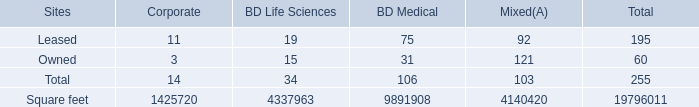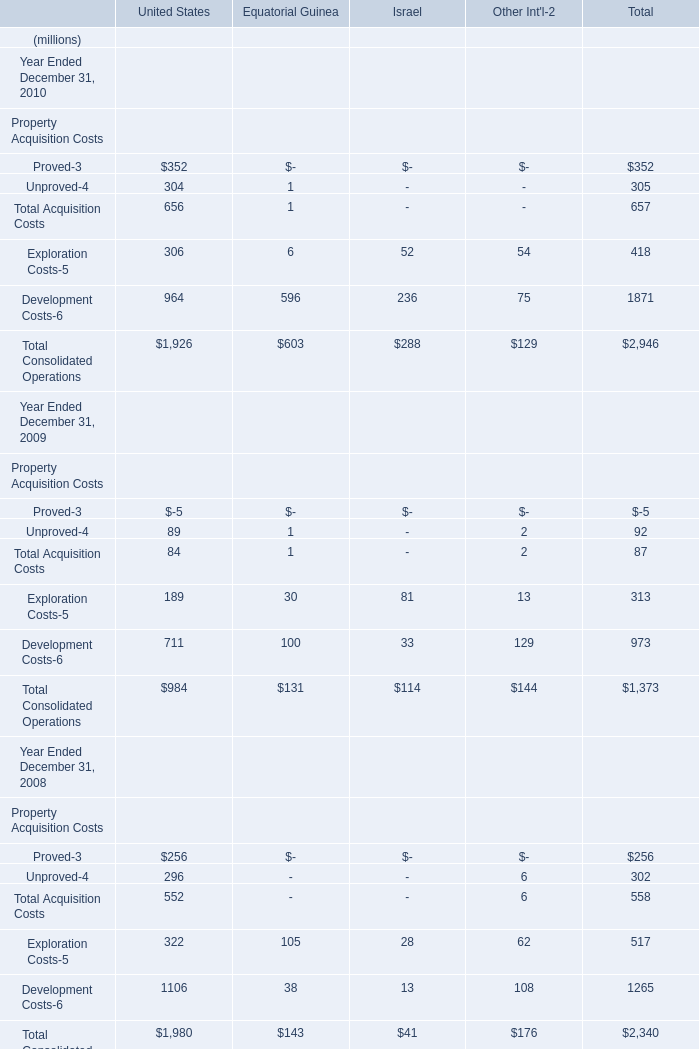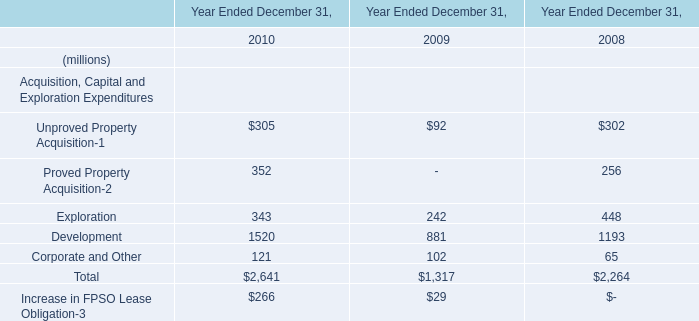If the Total Acquisition Costs in terms of United States develops with the same growth rate in 2010, what will it reach in 2011? (in million) 
Computations: (656 * (1 + ((656 - 84) / 84)))
Answer: 5123.04762. 